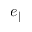<formula> <loc_0><loc_0><loc_500><loc_500>e _ { \| }</formula> 